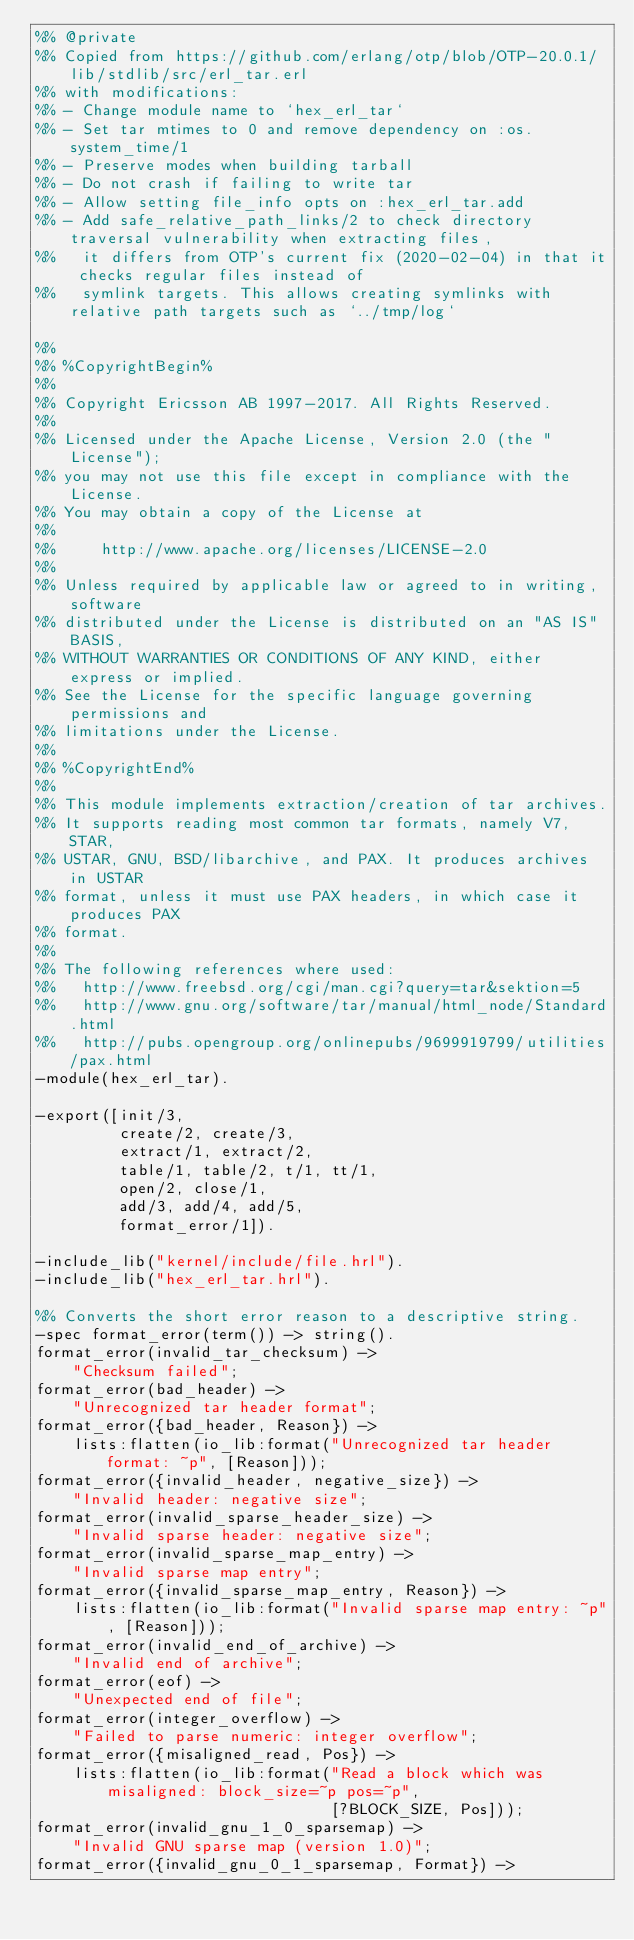Convert code to text. <code><loc_0><loc_0><loc_500><loc_500><_Erlang_>%% @private
%% Copied from https://github.com/erlang/otp/blob/OTP-20.0.1/lib/stdlib/src/erl_tar.erl
%% with modifications:
%% - Change module name to `hex_erl_tar`
%% - Set tar mtimes to 0 and remove dependency on :os.system_time/1
%% - Preserve modes when building tarball
%% - Do not crash if failing to write tar
%% - Allow setting file_info opts on :hex_erl_tar.add
%% - Add safe_relative_path_links/2 to check directory traversal vulnerability when extracting files,
%%   it differs from OTP's current fix (2020-02-04) in that it checks regular files instead of
%%   symlink targets. This allows creating symlinks with relative path targets such as `../tmp/log`

%%
%% %CopyrightBegin%
%%
%% Copyright Ericsson AB 1997-2017. All Rights Reserved.
%%
%% Licensed under the Apache License, Version 2.0 (the "License");
%% you may not use this file except in compliance with the License.
%% You may obtain a copy of the License at
%%
%%     http://www.apache.org/licenses/LICENSE-2.0
%%
%% Unless required by applicable law or agreed to in writing, software
%% distributed under the License is distributed on an "AS IS" BASIS,
%% WITHOUT WARRANTIES OR CONDITIONS OF ANY KIND, either express or implied.
%% See the License for the specific language governing permissions and
%% limitations under the License.
%%
%% %CopyrightEnd%
%%
%% This module implements extraction/creation of tar archives.
%% It supports reading most common tar formats, namely V7, STAR,
%% USTAR, GNU, BSD/libarchive, and PAX. It produces archives in USTAR
%% format, unless it must use PAX headers, in which case it produces PAX
%% format.
%%
%% The following references where used:
%%   http://www.freebsd.org/cgi/man.cgi?query=tar&sektion=5
%%   http://www.gnu.org/software/tar/manual/html_node/Standard.html
%%   http://pubs.opengroup.org/onlinepubs/9699919799/utilities/pax.html
-module(hex_erl_tar).

-export([init/3,
         create/2, create/3,
         extract/1, extract/2,
         table/1, table/2, t/1, tt/1,
         open/2, close/1,
         add/3, add/4, add/5,
         format_error/1]).

-include_lib("kernel/include/file.hrl").
-include_lib("hex_erl_tar.hrl").

%% Converts the short error reason to a descriptive string.
-spec format_error(term()) -> string().
format_error(invalid_tar_checksum) ->
    "Checksum failed";
format_error(bad_header) ->
    "Unrecognized tar header format";
format_error({bad_header, Reason}) ->
    lists:flatten(io_lib:format("Unrecognized tar header format: ~p", [Reason]));
format_error({invalid_header, negative_size}) ->
    "Invalid header: negative size";
format_error(invalid_sparse_header_size) ->
    "Invalid sparse header: negative size";
format_error(invalid_sparse_map_entry) ->
    "Invalid sparse map entry";
format_error({invalid_sparse_map_entry, Reason}) ->
    lists:flatten(io_lib:format("Invalid sparse map entry: ~p", [Reason]));
format_error(invalid_end_of_archive) ->
    "Invalid end of archive";
format_error(eof) ->
    "Unexpected end of file";
format_error(integer_overflow) ->
    "Failed to parse numeric: integer overflow";
format_error({misaligned_read, Pos}) ->
    lists:flatten(io_lib:format("Read a block which was misaligned: block_size=~p pos=~p",
                                [?BLOCK_SIZE, Pos]));
format_error(invalid_gnu_1_0_sparsemap) ->
    "Invalid GNU sparse map (version 1.0)";
format_error({invalid_gnu_0_1_sparsemap, Format}) -></code> 